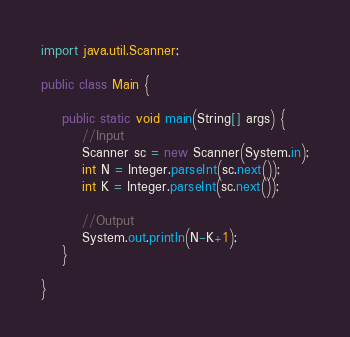<code> <loc_0><loc_0><loc_500><loc_500><_Java_>import java.util.Scanner;

public class Main {

	public static void main(String[] args) {
		//Input
		Scanner sc = new Scanner(System.in);
		int N = Integer.parseInt(sc.next());
		int K = Integer.parseInt(sc.next());

		//Output
		System.out.println(N-K+1);
	}

}
</code> 